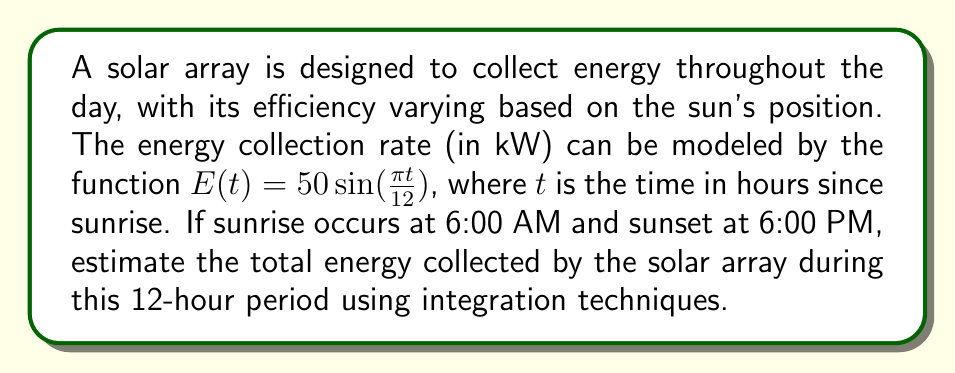Can you solve this math problem? To solve this problem, we need to integrate the energy collection rate function over the given time period. Let's approach this step-by-step:

1) The function $E(t) = 50 \sin(\frac{\pi t}{12})$ represents the energy collection rate in kW.

2) We need to integrate this function from $t=0$ (6:00 AM) to $t=12$ (6:00 PM) to get the total energy collected.

3) The integral we need to evaluate is:

   $$\int_0^{12} 50 \sin(\frac{\pi t}{12}) dt$$

4) To solve this, let's use the substitution method:
   Let $u = \frac{\pi t}{12}$, then $du = \frac{\pi}{12} dt$ or $dt = \frac{12}{\pi} du$

5) When $t=0$, $u=0$; when $t=12$, $u=\pi$

6) Substituting:

   $$\int_0^{\pi} 50 \sin(u) \cdot \frac{12}{\pi} du = \frac{600}{\pi} \int_0^{\pi} \sin(u) du$$

7) We know that $\int \sin(u) du = -\cos(u) + C$

8) Applying the limits:

   $$\frac{600}{\pi} [-\cos(u)]_0^{\pi} = \frac{600}{\pi} [-\cos(\pi) - (-\cos(0))]$$

9) $\cos(\pi) = -1$ and $\cos(0) = 1$, so:

   $$\frac{600}{\pi} [1 - (-1)] = \frac{600}{\pi} \cdot 2 = \frac{1200}{\pi}$$

10) This gives us the total energy in kWh.
Answer: $\frac{1200}{\pi}$ kWh 